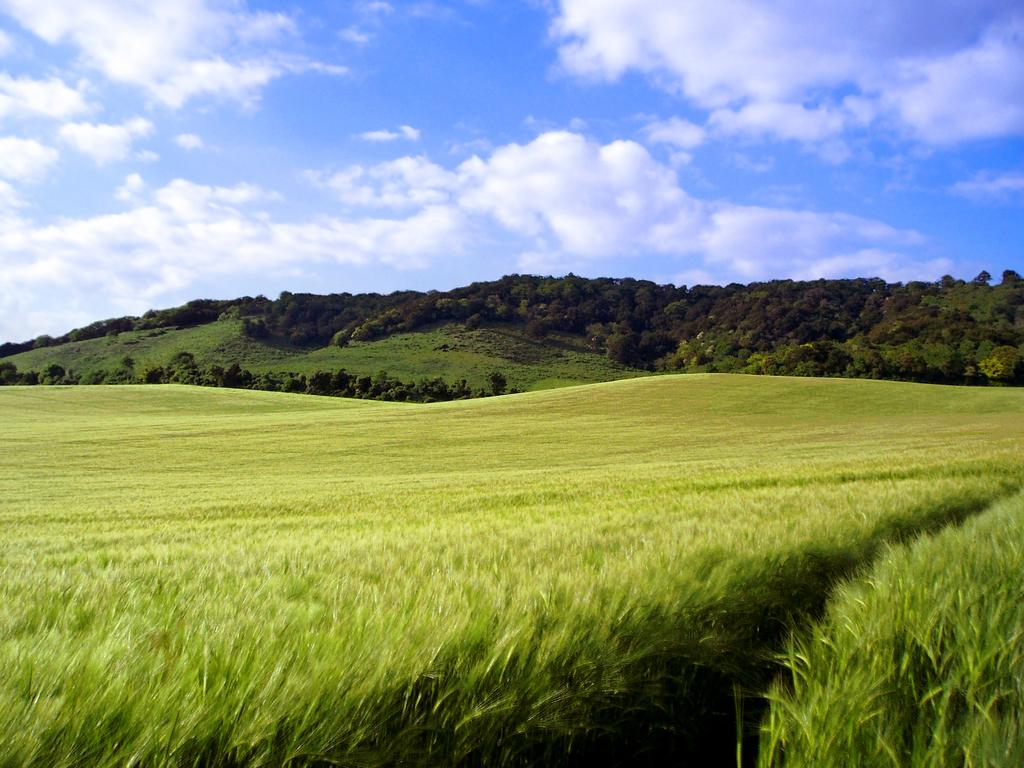What type of terrain is visible on the ground in the image? There is grass on the ground, resembling a field. What type of natural landmarks can be seen in the image? There are mountains and trees visible in the image. What is visible at the top of the image? The sky is visible at the top of the image. What can be seen in the sky in the image? Clouds are present in the sky. What reason does the bird have for being in the image? There is no bird present in the image, so it is not possible to determine a reason for its presence. 